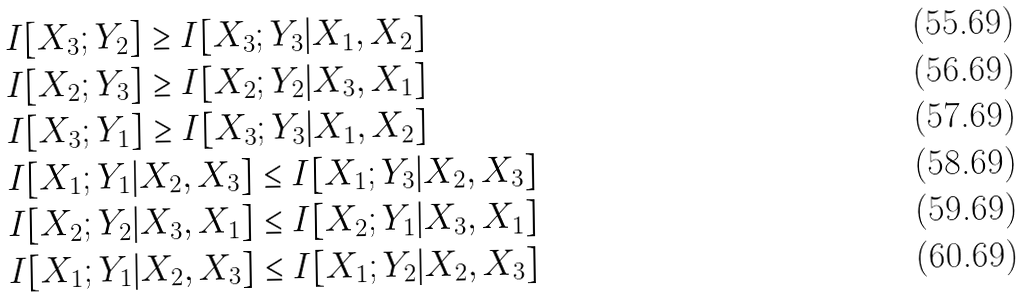Convert formula to latex. <formula><loc_0><loc_0><loc_500><loc_500>& I [ X _ { 3 } ; Y _ { 2 } ] \geq I [ X _ { 3 } ; Y _ { 3 } | X _ { 1 } , X _ { 2 } ] \\ & I [ X _ { 2 } ; Y _ { 3 } ] \geq I [ X _ { 2 } ; Y _ { 2 } | X _ { 3 } , X _ { 1 } ] \\ & I [ X _ { 3 } ; Y _ { 1 } ] \geq I [ X _ { 3 } ; Y _ { 3 } | X _ { 1 } , X _ { 2 } ] \\ & I [ X _ { 1 } ; Y _ { 1 } | X _ { 2 } , X _ { 3 } ] \leq I [ X _ { 1 } ; Y _ { 3 } | X _ { 2 } , X _ { 3 } ] \\ & I [ X _ { 2 } ; Y _ { 2 } | X _ { 3 } , X _ { 1 } ] \leq I [ X _ { 2 } ; Y _ { 1 } | X _ { 3 } , X _ { 1 } ] \\ & I [ X _ { 1 } ; Y _ { 1 } | X _ { 2 } , X _ { 3 } ] \leq I [ X _ { 1 } ; Y _ { 2 } | X _ { 2 } , X _ { 3 } ]</formula> 